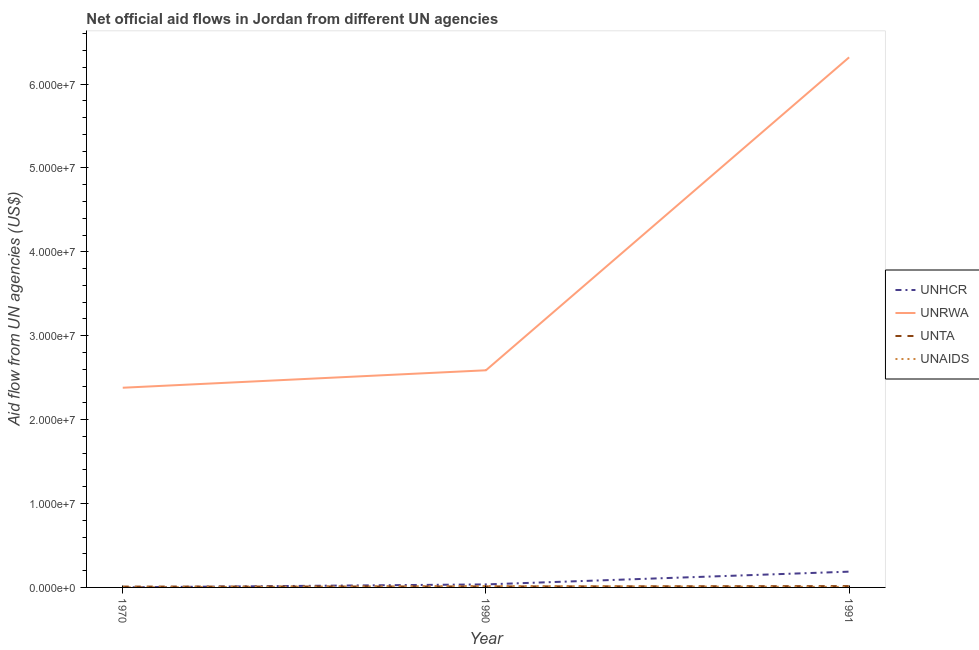Does the line corresponding to amount of aid given by unrwa intersect with the line corresponding to amount of aid given by unaids?
Give a very brief answer. No. What is the amount of aid given by unaids in 1991?
Provide a short and direct response. 6.00e+04. Across all years, what is the maximum amount of aid given by unaids?
Provide a succinct answer. 1.70e+05. Across all years, what is the minimum amount of aid given by unta?
Offer a terse response. 1.00e+05. What is the total amount of aid given by unrwa in the graph?
Your answer should be very brief. 1.13e+08. What is the difference between the amount of aid given by unaids in 1970 and that in 1990?
Provide a succinct answer. -1.60e+05. What is the difference between the amount of aid given by unta in 1991 and the amount of aid given by unaids in 1990?
Offer a terse response. -10000. In the year 1970, what is the difference between the amount of aid given by unhcr and amount of aid given by unrwa?
Offer a very short reply. -2.38e+07. What is the ratio of the amount of aid given by unta in 1990 to that in 1991?
Your answer should be compact. 0.75. What is the difference between the highest and the lowest amount of aid given by unta?
Ensure brevity in your answer.  6.00e+04. Is the sum of the amount of aid given by unhcr in 1990 and 1991 greater than the maximum amount of aid given by unta across all years?
Provide a succinct answer. Yes. Does the amount of aid given by unaids monotonically increase over the years?
Make the answer very short. No. How many years are there in the graph?
Offer a very short reply. 3. Are the values on the major ticks of Y-axis written in scientific E-notation?
Keep it short and to the point. Yes. How are the legend labels stacked?
Your answer should be compact. Vertical. What is the title of the graph?
Your response must be concise. Net official aid flows in Jordan from different UN agencies. What is the label or title of the Y-axis?
Your response must be concise. Aid flow from UN agencies (US$). What is the Aid flow from UN agencies (US$) of UNHCR in 1970?
Make the answer very short. 10000. What is the Aid flow from UN agencies (US$) in UNRWA in 1970?
Provide a succinct answer. 2.38e+07. What is the Aid flow from UN agencies (US$) of UNTA in 1970?
Ensure brevity in your answer.  1.00e+05. What is the Aid flow from UN agencies (US$) of UNAIDS in 1970?
Your answer should be very brief. 10000. What is the Aid flow from UN agencies (US$) in UNRWA in 1990?
Your response must be concise. 2.59e+07. What is the Aid flow from UN agencies (US$) in UNTA in 1990?
Provide a succinct answer. 1.20e+05. What is the Aid flow from UN agencies (US$) of UNHCR in 1991?
Your answer should be very brief. 1.88e+06. What is the Aid flow from UN agencies (US$) in UNRWA in 1991?
Make the answer very short. 6.32e+07. Across all years, what is the maximum Aid flow from UN agencies (US$) in UNHCR?
Make the answer very short. 1.88e+06. Across all years, what is the maximum Aid flow from UN agencies (US$) in UNRWA?
Give a very brief answer. 6.32e+07. Across all years, what is the maximum Aid flow from UN agencies (US$) in UNAIDS?
Ensure brevity in your answer.  1.70e+05. Across all years, what is the minimum Aid flow from UN agencies (US$) of UNRWA?
Offer a terse response. 2.38e+07. What is the total Aid flow from UN agencies (US$) of UNHCR in the graph?
Make the answer very short. 2.25e+06. What is the total Aid flow from UN agencies (US$) in UNRWA in the graph?
Your answer should be very brief. 1.13e+08. What is the total Aid flow from UN agencies (US$) in UNTA in the graph?
Provide a succinct answer. 3.80e+05. What is the difference between the Aid flow from UN agencies (US$) of UNHCR in 1970 and that in 1990?
Provide a succinct answer. -3.50e+05. What is the difference between the Aid flow from UN agencies (US$) of UNRWA in 1970 and that in 1990?
Offer a very short reply. -2.08e+06. What is the difference between the Aid flow from UN agencies (US$) of UNAIDS in 1970 and that in 1990?
Provide a succinct answer. -1.60e+05. What is the difference between the Aid flow from UN agencies (US$) of UNHCR in 1970 and that in 1991?
Your answer should be compact. -1.87e+06. What is the difference between the Aid flow from UN agencies (US$) of UNRWA in 1970 and that in 1991?
Offer a terse response. -3.94e+07. What is the difference between the Aid flow from UN agencies (US$) in UNAIDS in 1970 and that in 1991?
Make the answer very short. -5.00e+04. What is the difference between the Aid flow from UN agencies (US$) of UNHCR in 1990 and that in 1991?
Keep it short and to the point. -1.52e+06. What is the difference between the Aid flow from UN agencies (US$) of UNRWA in 1990 and that in 1991?
Give a very brief answer. -3.73e+07. What is the difference between the Aid flow from UN agencies (US$) of UNAIDS in 1990 and that in 1991?
Make the answer very short. 1.10e+05. What is the difference between the Aid flow from UN agencies (US$) in UNHCR in 1970 and the Aid flow from UN agencies (US$) in UNRWA in 1990?
Your answer should be very brief. -2.59e+07. What is the difference between the Aid flow from UN agencies (US$) in UNHCR in 1970 and the Aid flow from UN agencies (US$) in UNTA in 1990?
Your answer should be very brief. -1.10e+05. What is the difference between the Aid flow from UN agencies (US$) in UNHCR in 1970 and the Aid flow from UN agencies (US$) in UNAIDS in 1990?
Your answer should be very brief. -1.60e+05. What is the difference between the Aid flow from UN agencies (US$) of UNRWA in 1970 and the Aid flow from UN agencies (US$) of UNTA in 1990?
Offer a terse response. 2.37e+07. What is the difference between the Aid flow from UN agencies (US$) of UNRWA in 1970 and the Aid flow from UN agencies (US$) of UNAIDS in 1990?
Your answer should be compact. 2.36e+07. What is the difference between the Aid flow from UN agencies (US$) in UNHCR in 1970 and the Aid flow from UN agencies (US$) in UNRWA in 1991?
Offer a very short reply. -6.32e+07. What is the difference between the Aid flow from UN agencies (US$) in UNRWA in 1970 and the Aid flow from UN agencies (US$) in UNTA in 1991?
Your answer should be compact. 2.36e+07. What is the difference between the Aid flow from UN agencies (US$) of UNRWA in 1970 and the Aid flow from UN agencies (US$) of UNAIDS in 1991?
Provide a short and direct response. 2.37e+07. What is the difference between the Aid flow from UN agencies (US$) in UNHCR in 1990 and the Aid flow from UN agencies (US$) in UNRWA in 1991?
Keep it short and to the point. -6.28e+07. What is the difference between the Aid flow from UN agencies (US$) of UNHCR in 1990 and the Aid flow from UN agencies (US$) of UNAIDS in 1991?
Keep it short and to the point. 3.00e+05. What is the difference between the Aid flow from UN agencies (US$) of UNRWA in 1990 and the Aid flow from UN agencies (US$) of UNTA in 1991?
Provide a succinct answer. 2.57e+07. What is the difference between the Aid flow from UN agencies (US$) in UNRWA in 1990 and the Aid flow from UN agencies (US$) in UNAIDS in 1991?
Ensure brevity in your answer.  2.58e+07. What is the average Aid flow from UN agencies (US$) in UNHCR per year?
Give a very brief answer. 7.50e+05. What is the average Aid flow from UN agencies (US$) in UNRWA per year?
Your answer should be compact. 3.76e+07. What is the average Aid flow from UN agencies (US$) of UNTA per year?
Ensure brevity in your answer.  1.27e+05. In the year 1970, what is the difference between the Aid flow from UN agencies (US$) of UNHCR and Aid flow from UN agencies (US$) of UNRWA?
Your answer should be very brief. -2.38e+07. In the year 1970, what is the difference between the Aid flow from UN agencies (US$) in UNHCR and Aid flow from UN agencies (US$) in UNTA?
Offer a very short reply. -9.00e+04. In the year 1970, what is the difference between the Aid flow from UN agencies (US$) in UNRWA and Aid flow from UN agencies (US$) in UNTA?
Offer a terse response. 2.37e+07. In the year 1970, what is the difference between the Aid flow from UN agencies (US$) of UNRWA and Aid flow from UN agencies (US$) of UNAIDS?
Your answer should be compact. 2.38e+07. In the year 1970, what is the difference between the Aid flow from UN agencies (US$) of UNTA and Aid flow from UN agencies (US$) of UNAIDS?
Provide a succinct answer. 9.00e+04. In the year 1990, what is the difference between the Aid flow from UN agencies (US$) in UNHCR and Aid flow from UN agencies (US$) in UNRWA?
Offer a very short reply. -2.55e+07. In the year 1990, what is the difference between the Aid flow from UN agencies (US$) of UNRWA and Aid flow from UN agencies (US$) of UNTA?
Make the answer very short. 2.58e+07. In the year 1990, what is the difference between the Aid flow from UN agencies (US$) in UNRWA and Aid flow from UN agencies (US$) in UNAIDS?
Keep it short and to the point. 2.57e+07. In the year 1991, what is the difference between the Aid flow from UN agencies (US$) of UNHCR and Aid flow from UN agencies (US$) of UNRWA?
Give a very brief answer. -6.13e+07. In the year 1991, what is the difference between the Aid flow from UN agencies (US$) of UNHCR and Aid flow from UN agencies (US$) of UNTA?
Keep it short and to the point. 1.72e+06. In the year 1991, what is the difference between the Aid flow from UN agencies (US$) in UNHCR and Aid flow from UN agencies (US$) in UNAIDS?
Provide a short and direct response. 1.82e+06. In the year 1991, what is the difference between the Aid flow from UN agencies (US$) of UNRWA and Aid flow from UN agencies (US$) of UNTA?
Keep it short and to the point. 6.30e+07. In the year 1991, what is the difference between the Aid flow from UN agencies (US$) in UNRWA and Aid flow from UN agencies (US$) in UNAIDS?
Offer a very short reply. 6.31e+07. What is the ratio of the Aid flow from UN agencies (US$) of UNHCR in 1970 to that in 1990?
Your answer should be very brief. 0.03. What is the ratio of the Aid flow from UN agencies (US$) of UNRWA in 1970 to that in 1990?
Offer a terse response. 0.92. What is the ratio of the Aid flow from UN agencies (US$) in UNAIDS in 1970 to that in 1990?
Make the answer very short. 0.06. What is the ratio of the Aid flow from UN agencies (US$) of UNHCR in 1970 to that in 1991?
Your answer should be very brief. 0.01. What is the ratio of the Aid flow from UN agencies (US$) of UNRWA in 1970 to that in 1991?
Provide a short and direct response. 0.38. What is the ratio of the Aid flow from UN agencies (US$) in UNAIDS in 1970 to that in 1991?
Make the answer very short. 0.17. What is the ratio of the Aid flow from UN agencies (US$) of UNHCR in 1990 to that in 1991?
Your response must be concise. 0.19. What is the ratio of the Aid flow from UN agencies (US$) in UNRWA in 1990 to that in 1991?
Your response must be concise. 0.41. What is the ratio of the Aid flow from UN agencies (US$) of UNAIDS in 1990 to that in 1991?
Make the answer very short. 2.83. What is the difference between the highest and the second highest Aid flow from UN agencies (US$) of UNHCR?
Give a very brief answer. 1.52e+06. What is the difference between the highest and the second highest Aid flow from UN agencies (US$) in UNRWA?
Give a very brief answer. 3.73e+07. What is the difference between the highest and the second highest Aid flow from UN agencies (US$) of UNAIDS?
Keep it short and to the point. 1.10e+05. What is the difference between the highest and the lowest Aid flow from UN agencies (US$) in UNHCR?
Offer a very short reply. 1.87e+06. What is the difference between the highest and the lowest Aid flow from UN agencies (US$) in UNRWA?
Offer a terse response. 3.94e+07. What is the difference between the highest and the lowest Aid flow from UN agencies (US$) in UNTA?
Make the answer very short. 6.00e+04. What is the difference between the highest and the lowest Aid flow from UN agencies (US$) in UNAIDS?
Your answer should be compact. 1.60e+05. 